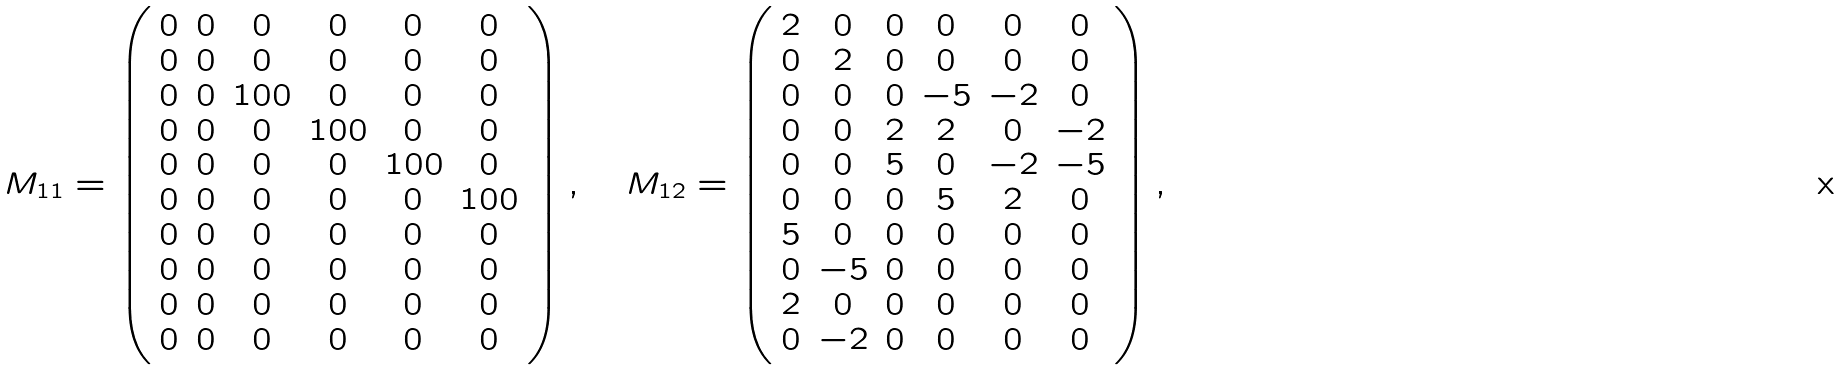<formula> <loc_0><loc_0><loc_500><loc_500>M _ { 1 1 } = \left ( \begin{array} { c c c c c c } 0 & 0 & 0 & 0 & 0 & 0 \\ 0 & 0 & 0 & 0 & 0 & 0 \\ 0 & 0 & 1 0 0 & 0 & 0 & 0 \\ 0 & 0 & 0 & 1 0 0 & 0 & 0 \\ 0 & 0 & 0 & 0 & 1 0 0 & 0 \\ 0 & 0 & 0 & 0 & 0 & 1 0 0 \\ 0 & 0 & 0 & 0 & 0 & 0 \\ 0 & 0 & 0 & 0 & 0 & 0 \\ 0 & 0 & 0 & 0 & 0 & 0 \\ 0 & 0 & 0 & 0 & 0 & 0 \\ \end{array} \right ) , \quad M _ { 1 2 } = \left ( \begin{array} { c c c c c c } 2 & 0 & 0 & 0 & 0 & 0 \\ 0 & 2 & 0 & 0 & 0 & 0 \\ 0 & 0 & 0 & - 5 & - 2 & 0 \\ 0 & 0 & 2 & 2 & 0 & - 2 \\ 0 & 0 & 5 & 0 & - 2 & - 5 \\ 0 & 0 & 0 & 5 & 2 & 0 \\ 5 & 0 & 0 & 0 & 0 & 0 \\ 0 & - 5 & 0 & 0 & 0 & 0 \\ 2 & 0 & 0 & 0 & 0 & 0 \\ 0 & - 2 & 0 & 0 & 0 & 0 \\ \end{array} \right ) , \quad</formula> 